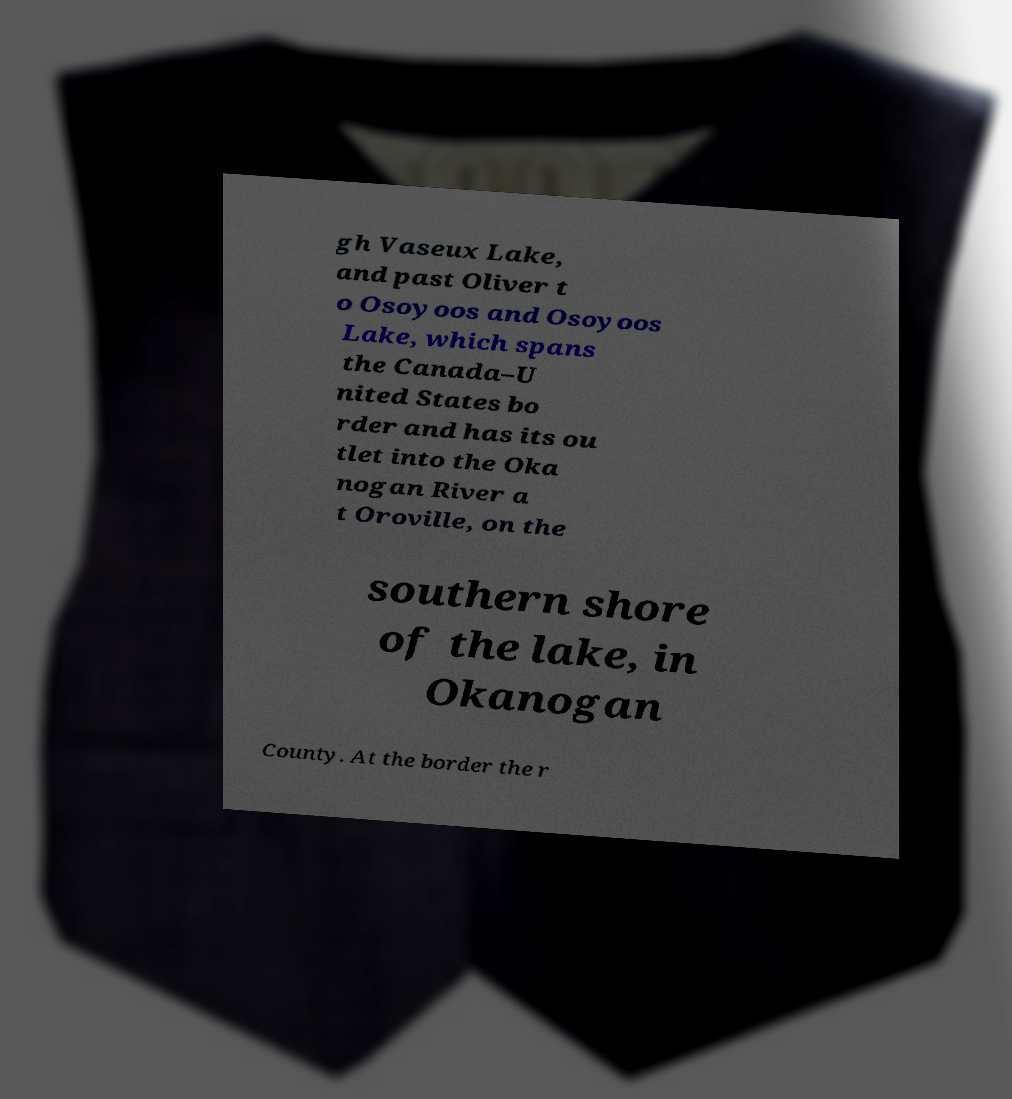Please identify and transcribe the text found in this image. gh Vaseux Lake, and past Oliver t o Osoyoos and Osoyoos Lake, which spans the Canada–U nited States bo rder and has its ou tlet into the Oka nogan River a t Oroville, on the southern shore of the lake, in Okanogan County. At the border the r 